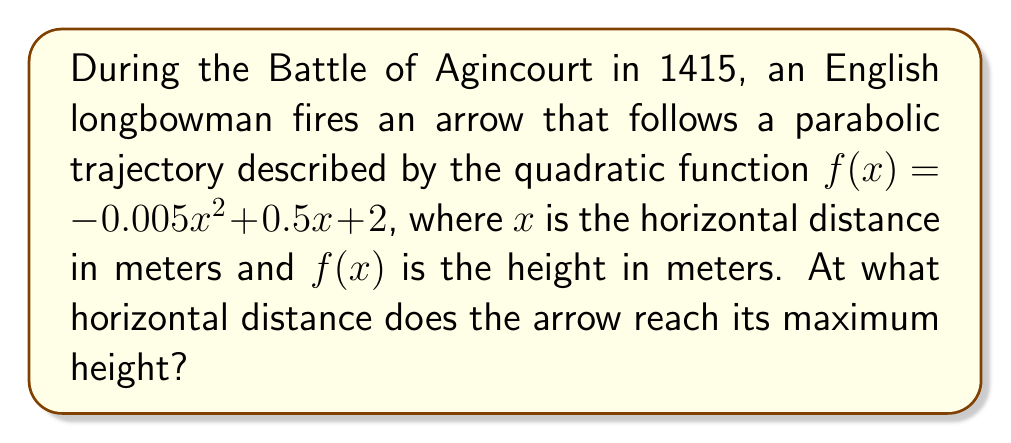Teach me how to tackle this problem. To find the maximum height of a quadratic function, we need to determine the x-coordinate of the vertex. For a quadratic function in the form $f(x) = ax^2 + bx + c$, the x-coordinate of the vertex is given by the formula:

$$ x = -\frac{b}{2a} $$

In our case:
$a = -0.005$
$b = 0.5$
$c = 2$

Substituting these values into the formula:

$$ x = -\frac{0.5}{2(-0.005)} = -\frac{0.5}{-0.01} = 50 $$

Therefore, the arrow reaches its maximum height when the horizontal distance is 50 meters.

As a historical note, the longbow was indeed a crucial weapon at the Battle of Agincourt, allowing the English to defeat a numerically superior French force.
Answer: 50 meters 